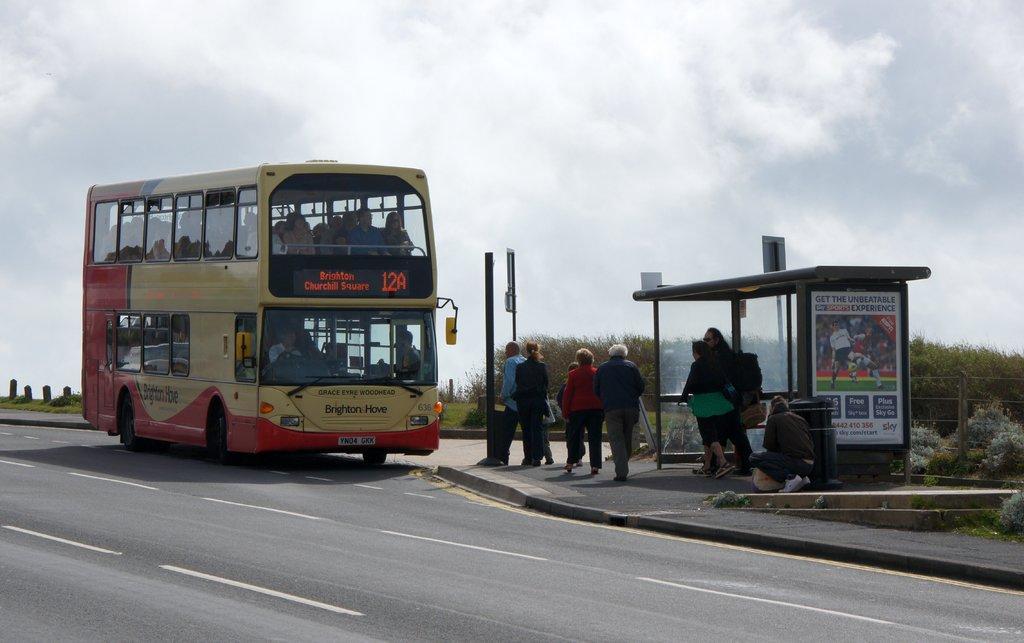Could you give a brief overview of what you see in this image? In this image there is a bus on the road. Few persons are inside the bus. Few persons are on the pavement having a dustbin and few poles. Right side there are few trees and plants on the grassland. Top of the image there is sky. Right side there is a bus stop on the pavement. 